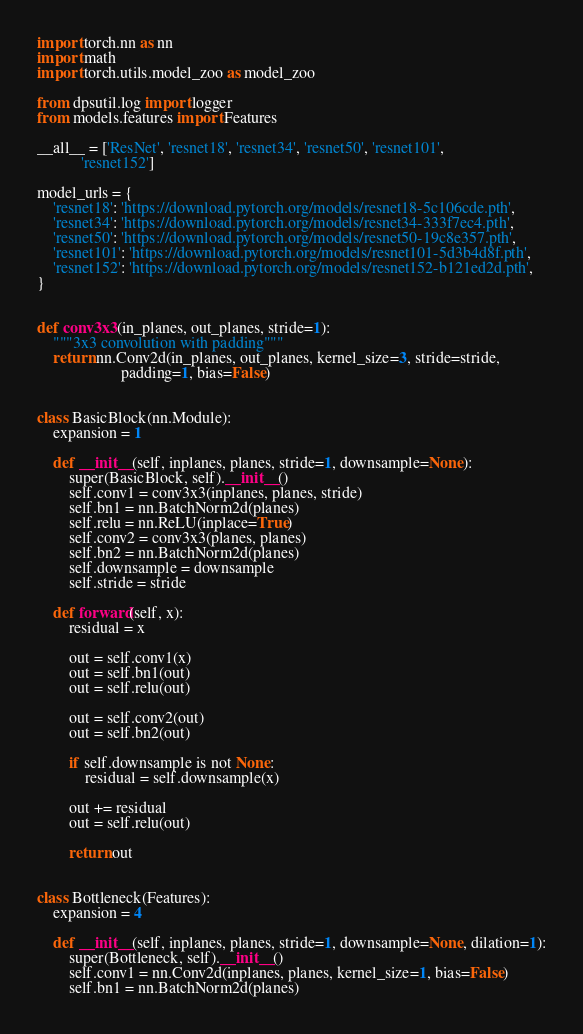Convert code to text. <code><loc_0><loc_0><loc_500><loc_500><_Python_>import torch.nn as nn
import math
import torch.utils.model_zoo as model_zoo

from dpsutil.log import logger
from models.features import Features

__all__ = ['ResNet', 'resnet18', 'resnet34', 'resnet50', 'resnet101',
           'resnet152']

model_urls = {
    'resnet18': 'https://download.pytorch.org/models/resnet18-5c106cde.pth',
    'resnet34': 'https://download.pytorch.org/models/resnet34-333f7ec4.pth',
    'resnet50': 'https://download.pytorch.org/models/resnet50-19c8e357.pth',
    'resnet101': 'https://download.pytorch.org/models/resnet101-5d3b4d8f.pth',
    'resnet152': 'https://download.pytorch.org/models/resnet152-b121ed2d.pth',
}


def conv3x3(in_planes, out_planes, stride=1):
    """3x3 convolution with padding"""
    return nn.Conv2d(in_planes, out_planes, kernel_size=3, stride=stride,
                     padding=1, bias=False)


class BasicBlock(nn.Module):
    expansion = 1

    def __init__(self, inplanes, planes, stride=1, downsample=None):
        super(BasicBlock, self).__init__()
        self.conv1 = conv3x3(inplanes, planes, stride)
        self.bn1 = nn.BatchNorm2d(planes)
        self.relu = nn.ReLU(inplace=True)
        self.conv2 = conv3x3(planes, planes)
        self.bn2 = nn.BatchNorm2d(planes)
        self.downsample = downsample
        self.stride = stride

    def forward(self, x):
        residual = x

        out = self.conv1(x)
        out = self.bn1(out)
        out = self.relu(out)

        out = self.conv2(out)
        out = self.bn2(out)

        if self.downsample is not None:
            residual = self.downsample(x)

        out += residual
        out = self.relu(out)

        return out


class Bottleneck(Features):
    expansion = 4

    def __init__(self, inplanes, planes, stride=1, downsample=None, dilation=1):
        super(Bottleneck, self).__init__()
        self.conv1 = nn.Conv2d(inplanes, planes, kernel_size=1, bias=False)
        self.bn1 = nn.BatchNorm2d(planes)</code> 